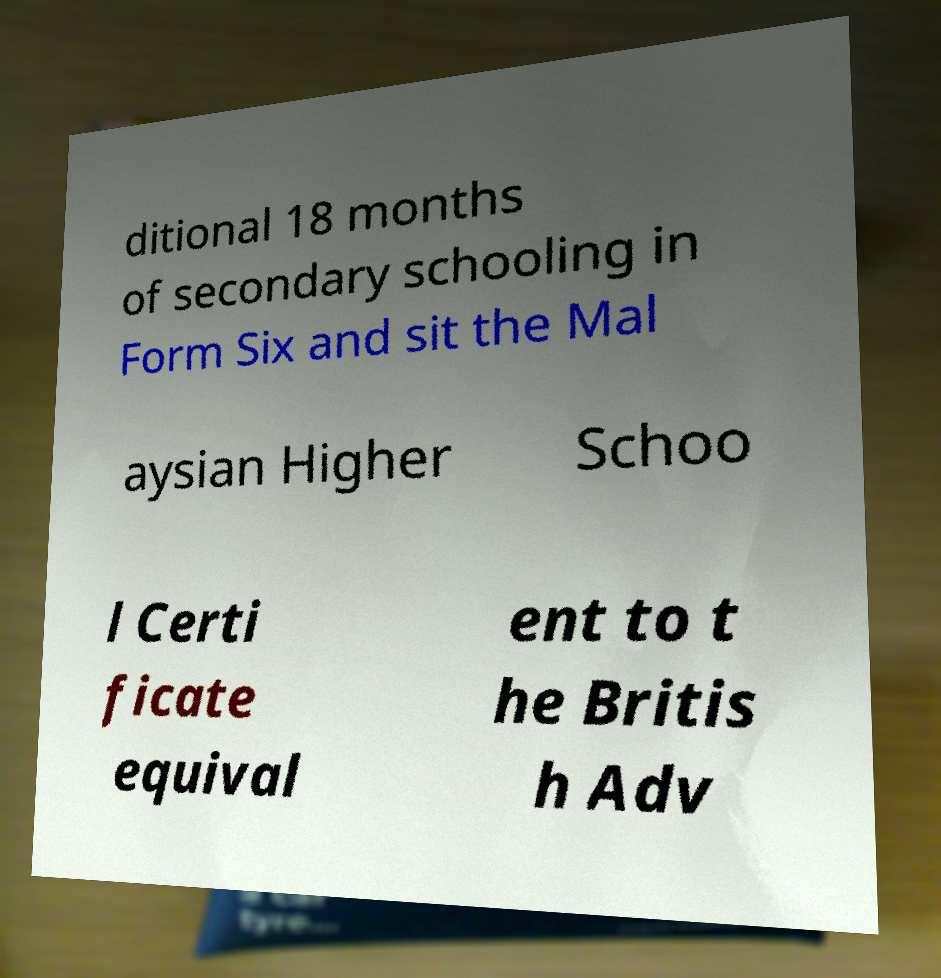Please read and relay the text visible in this image. What does it say? ditional 18 months of secondary schooling in Form Six and sit the Mal aysian Higher Schoo l Certi ficate equival ent to t he Britis h Adv 